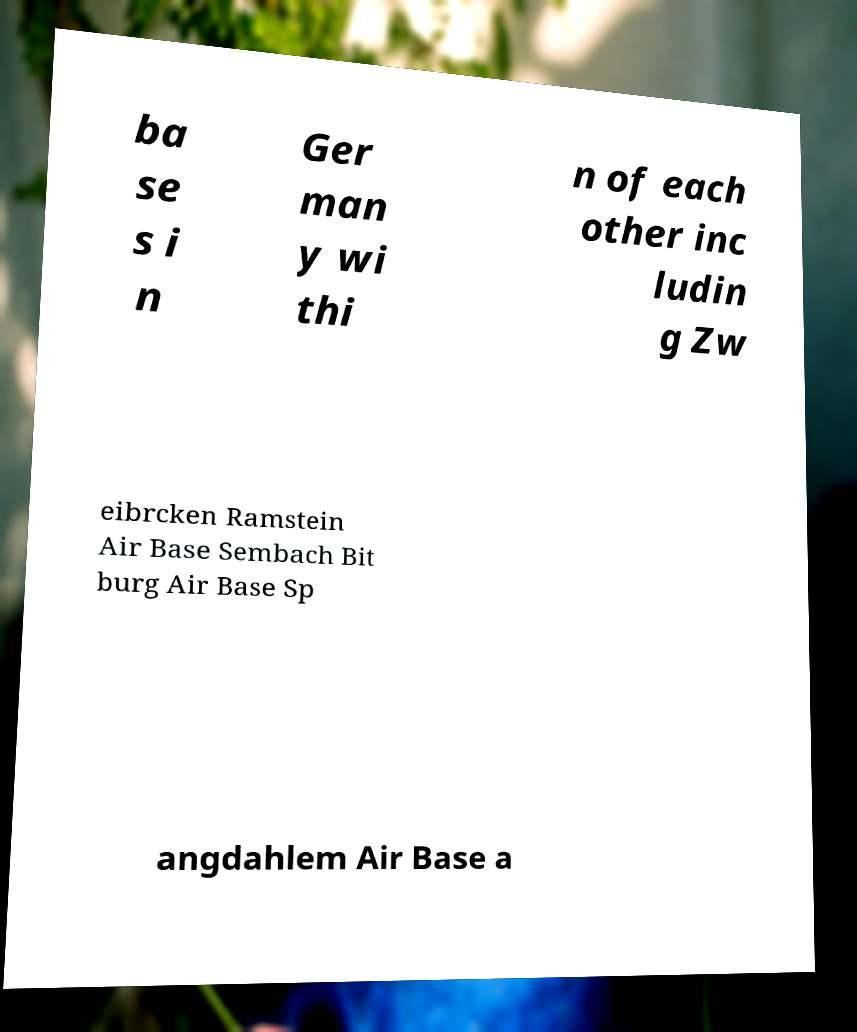There's text embedded in this image that I need extracted. Can you transcribe it verbatim? ba se s i n Ger man y wi thi n of each other inc ludin g Zw eibrcken Ramstein Air Base Sembach Bit burg Air Base Sp angdahlem Air Base a 